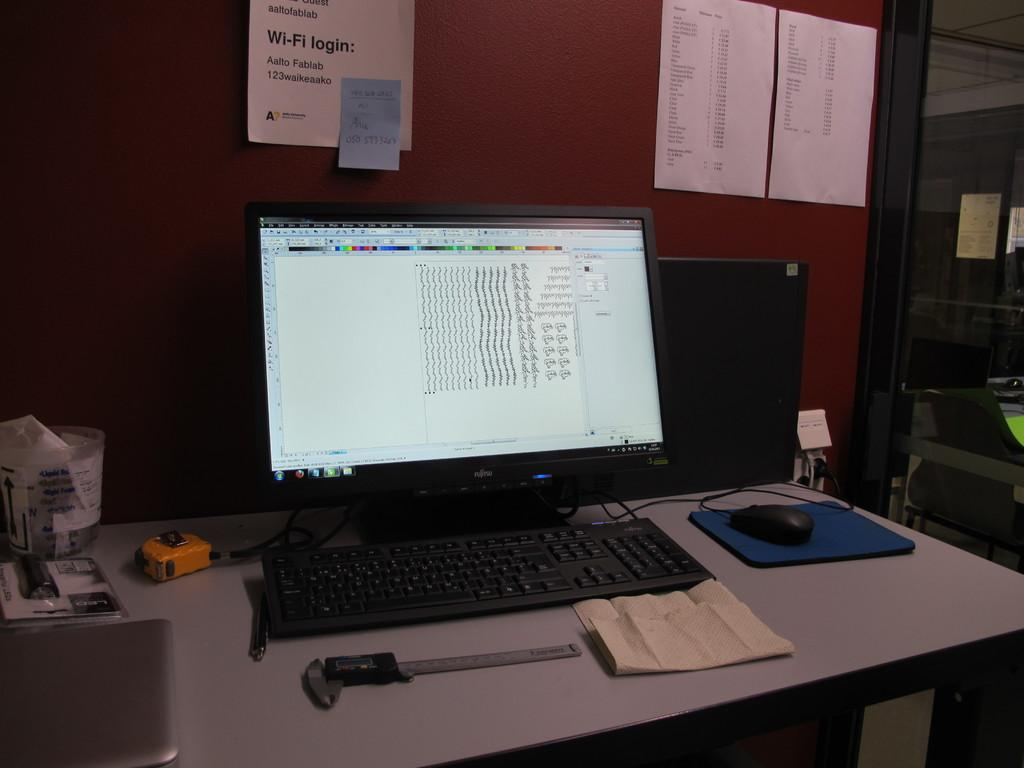What type of electronic device is visible in the image? There is a monitor in the image. What is used for input with the monitor? There is a keyboard in the image. What is the paper used for in the image? There is a quotation on the paper. What is used for controlling the cursor on the monitor? There is a mouse in the image. What can be seen on the table in the image? There are objects on the table. What is visible in the background of the image? There is a wallpaper in the background. What type of rake is used in the image? There is no rake present in the image. --- Facts: 1. There is a person in the image. 12. The person is wearing a hat. 13. The person is holding a book. 14. The person is sitting on a chair. 15. There is a table in the image. 16. There is a lamp on the table. 17. The background is a room. 18. The room has a wooden floor. 19. The room has a window. 120. The window has curtains. Absurd Topics: unicorn, umbrella, umbrella stand Conversation: Who or what is in the image? There is a person in the image. What is the person wearing on their head? The person is wearing a hat. What is the person holding in their hands? The person is holding a book. What is the person sitting on? The person is sitting on a chair. What is on the table in the image? There is a table lamp on the table. What type of room is visible in the background? The background is a room. What type of flooring is present in the room? The room has a wooden floor. What type of window is present in the room? The window has curtains. Reasoning: Let's think step by step in order to produce the conversation. We start by identifying the main subject in the image, which is the person. Then, we describe specific details about the person, such as their hat and the book they are holding. Next, we observe the person's sitting position and the presence of a table and a lamp on the table. After that, we describe the type of room visible in the background, including details about the flooring and the window with curtains. Absurd Question/Answer: Can you see a unicorn in the image? There is no unicorn present in the image. --- Facts: 1. There is a person in the image. 12. The person is wearing a hat. 13. The person is holding a book. 14. The person is sitting on a chair. 15. There is a table in 